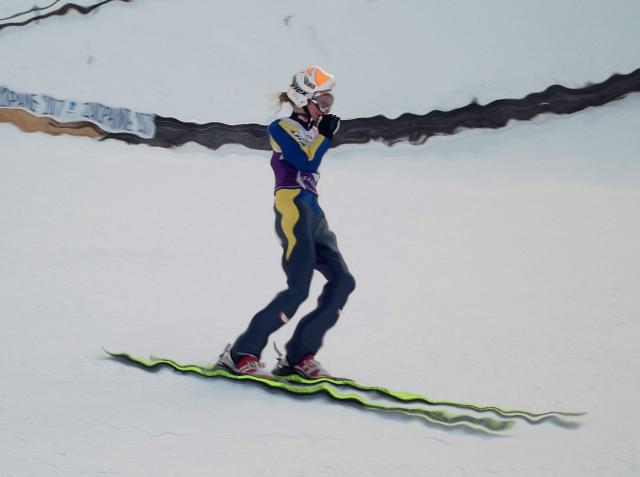What kind of equipment is the person using? The individual is using a snowboard, which is attached to their feet with bindings. The snowboard appears to have a curved tip and tail, which are features that assist in maneuverability and stability on the snow. 